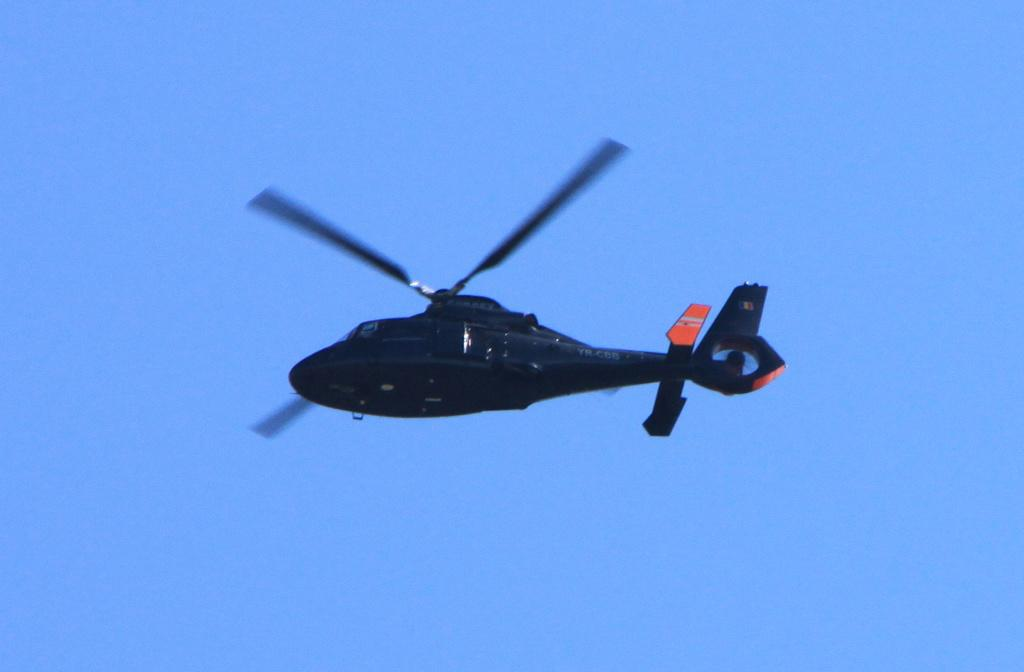What is the main subject of the image? The main subject of the image is a helicopter. What is the helicopter doing in the image? The helicopter is flying in the sky. What type of appliance can be seen on the skin of the person in the image? There is no person or appliance visible on the skin in the image; it features a helicopter flying in the sky. 